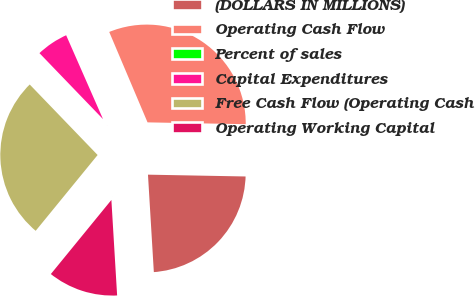Convert chart to OTSL. <chart><loc_0><loc_0><loc_500><loc_500><pie_chart><fcel>(DOLLARS IN MILLIONS)<fcel>Operating Cash Flow<fcel>Percent of sales<fcel>Capital Expenditures<fcel>Free Cash Flow (Operating Cash<fcel>Operating Working Capital<nl><fcel>23.75%<fcel>31.68%<fcel>0.21%<fcel>5.61%<fcel>26.9%<fcel>11.86%<nl></chart> 